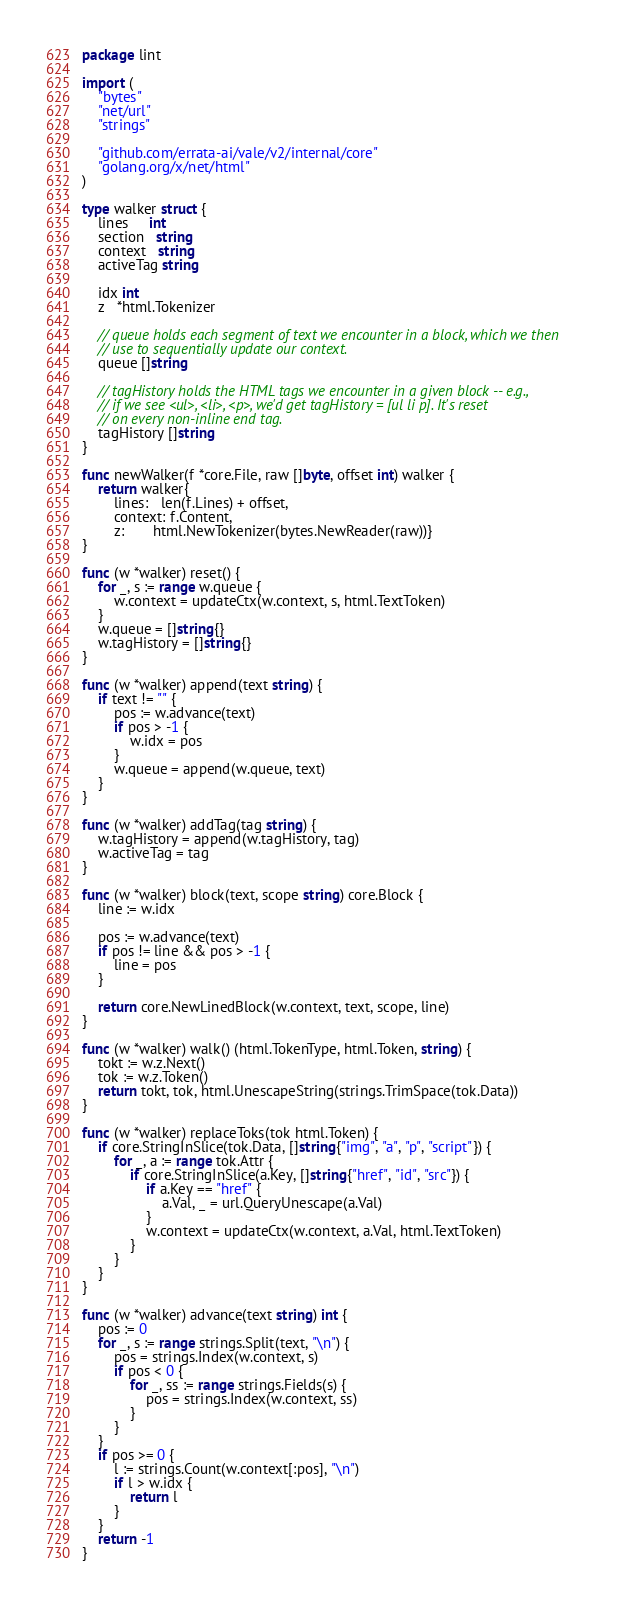Convert code to text. <code><loc_0><loc_0><loc_500><loc_500><_Go_>package lint

import (
	"bytes"
	"net/url"
	"strings"

	"github.com/errata-ai/vale/v2/internal/core"
	"golang.org/x/net/html"
)

type walker struct {
	lines     int
	section   string
	context   string
	activeTag string

	idx int
	z   *html.Tokenizer

	// queue holds each segment of text we encounter in a block, which we then
	// use to sequentially update our context.
	queue []string

	// tagHistory holds the HTML tags we encounter in a given block -- e.g.,
	// if we see <ul>, <li>, <p>, we'd get tagHistory = [ul li p]. It's reset
	// on every non-inline end tag.
	tagHistory []string
}

func newWalker(f *core.File, raw []byte, offset int) walker {
	return walker{
		lines:   len(f.Lines) + offset,
		context: f.Content,
		z:       html.NewTokenizer(bytes.NewReader(raw))}
}

func (w *walker) reset() {
	for _, s := range w.queue {
		w.context = updateCtx(w.context, s, html.TextToken)
	}
	w.queue = []string{}
	w.tagHistory = []string{}
}

func (w *walker) append(text string) {
	if text != "" {
		pos := w.advance(text)
		if pos > -1 {
			w.idx = pos
		}
		w.queue = append(w.queue, text)
	}
}

func (w *walker) addTag(tag string) {
	w.tagHistory = append(w.tagHistory, tag)
	w.activeTag = tag
}

func (w *walker) block(text, scope string) core.Block {
	line := w.idx

	pos := w.advance(text)
	if pos != line && pos > -1 {
		line = pos
	}

	return core.NewLinedBlock(w.context, text, scope, line)
}

func (w *walker) walk() (html.TokenType, html.Token, string) {
	tokt := w.z.Next()
	tok := w.z.Token()
	return tokt, tok, html.UnescapeString(strings.TrimSpace(tok.Data))
}

func (w *walker) replaceToks(tok html.Token) {
	if core.StringInSlice(tok.Data, []string{"img", "a", "p", "script"}) {
		for _, a := range tok.Attr {
			if core.StringInSlice(a.Key, []string{"href", "id", "src"}) {
				if a.Key == "href" {
					a.Val, _ = url.QueryUnescape(a.Val)
				}
				w.context = updateCtx(w.context, a.Val, html.TextToken)
			}
		}
	}
}

func (w *walker) advance(text string) int {
	pos := 0
	for _, s := range strings.Split(text, "\n") {
		pos = strings.Index(w.context, s)
		if pos < 0 {
			for _, ss := range strings.Fields(s) {
				pos = strings.Index(w.context, ss)
			}
		}
	}
	if pos >= 0 {
		l := strings.Count(w.context[:pos], "\n")
		if l > w.idx {
			return l
		}
	}
	return -1
}
</code> 